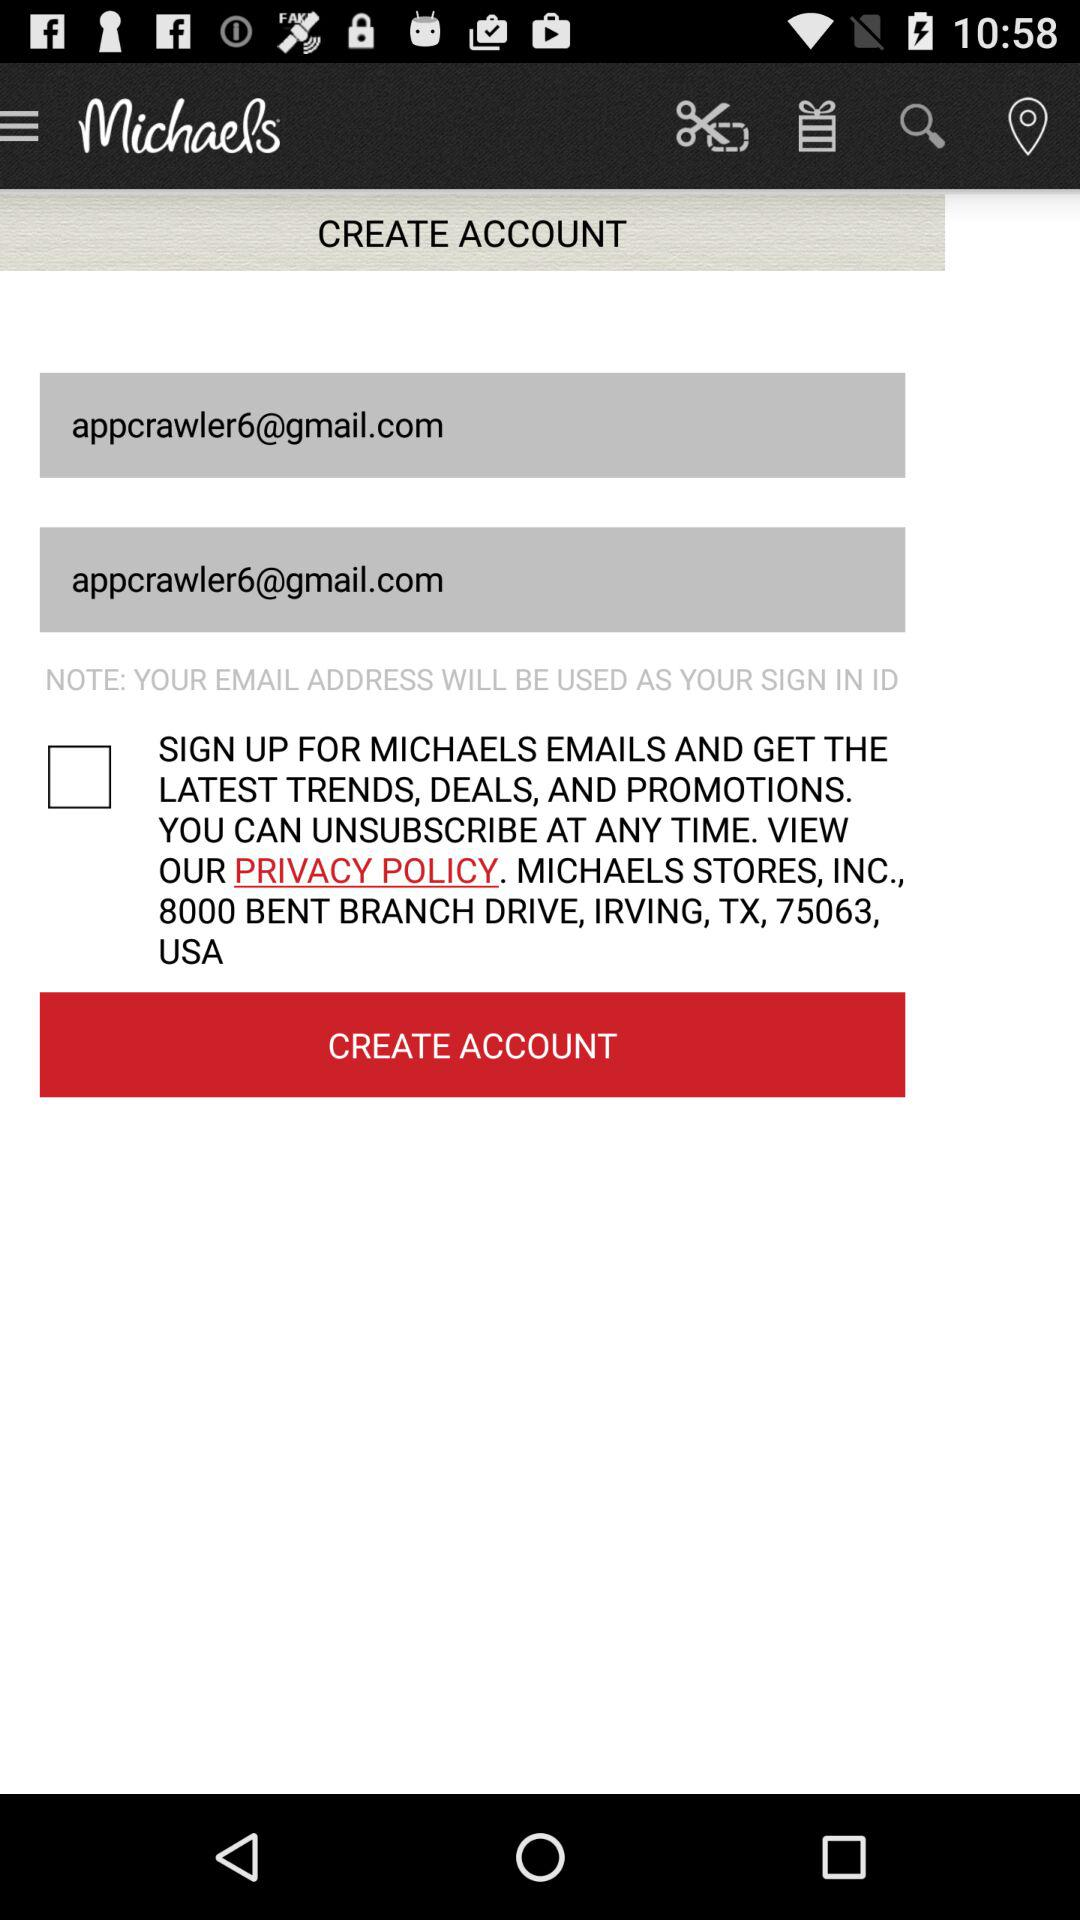How many text inputs are there for email addresses?
Answer the question using a single word or phrase. 2 